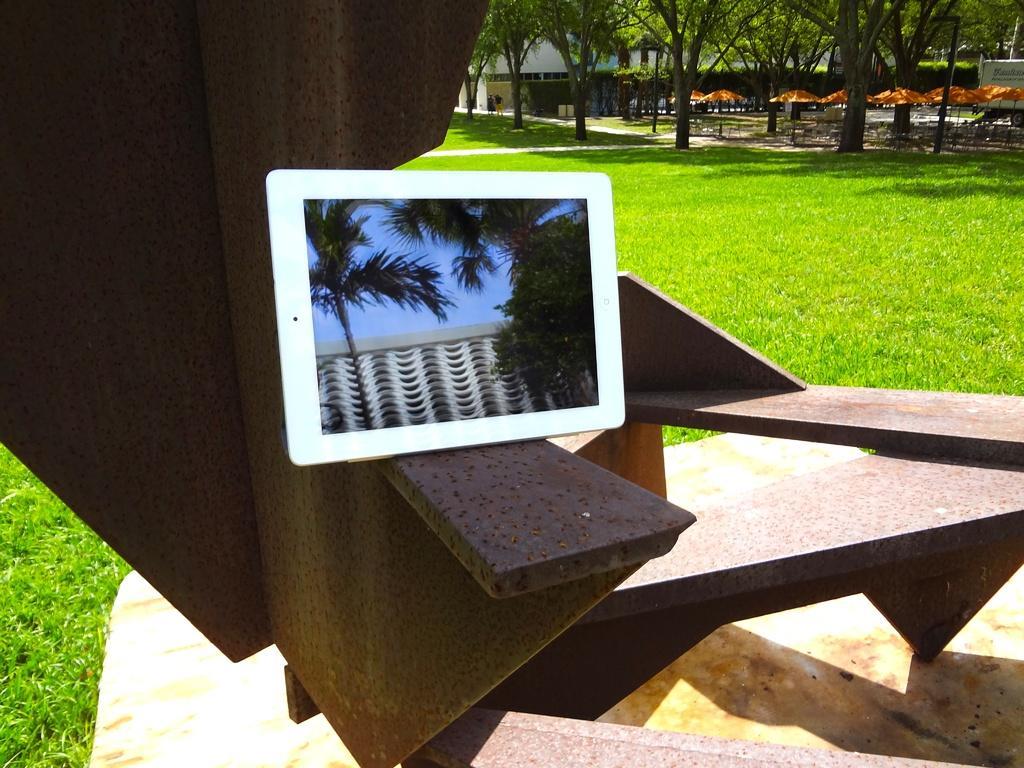How would you summarize this image in a sentence or two? In the center of the image, we can see a tab on the stairs and in the background, trees, sheds, tents, poles and there is a vehicle. At the bottom, there is ground covered with grass. 